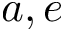Convert formula to latex. <formula><loc_0><loc_0><loc_500><loc_500>a , e</formula> 